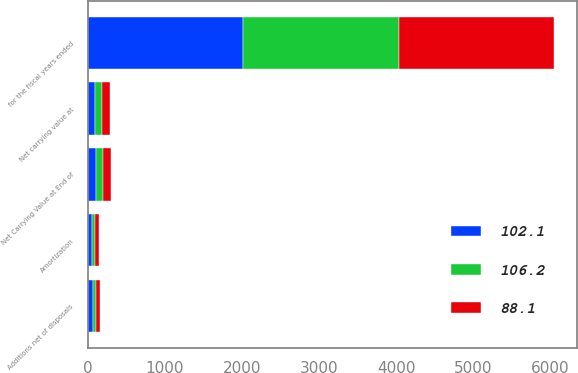<chart> <loc_0><loc_0><loc_500><loc_500><stacked_bar_chart><ecel><fcel>for the fiscal years ended<fcel>Net carrying value at<fcel>Additions net of disposals<fcel>Amortization<fcel>Net Carrying Value at End of<nl><fcel>88.1<fcel>2018<fcel>102.1<fcel>51.2<fcel>47.1<fcel>106.2<nl><fcel>102.1<fcel>2017<fcel>88.1<fcel>63.1<fcel>49.1<fcel>102.1<nl><fcel>106.2<fcel>2016<fcel>89.8<fcel>46.2<fcel>47.9<fcel>88.1<nl></chart> 